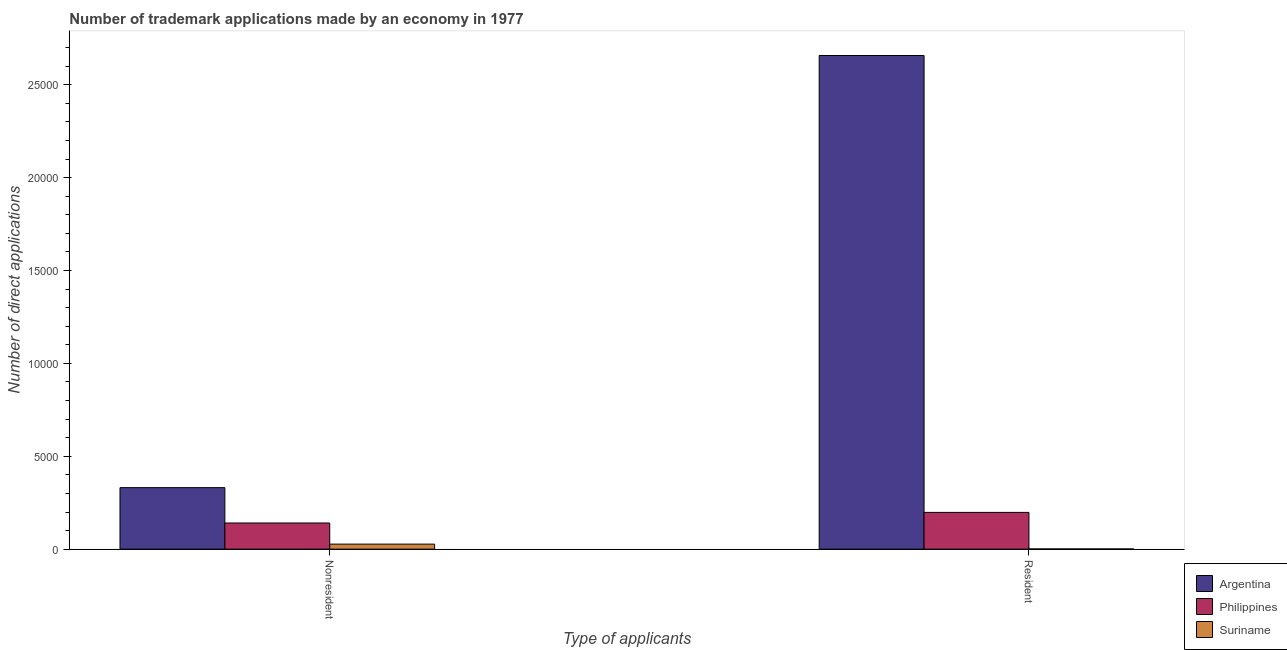How many different coloured bars are there?
Make the answer very short. 3. How many groups of bars are there?
Provide a succinct answer. 2. Are the number of bars on each tick of the X-axis equal?
Ensure brevity in your answer.  Yes. How many bars are there on the 2nd tick from the left?
Ensure brevity in your answer.  3. How many bars are there on the 2nd tick from the right?
Make the answer very short. 3. What is the label of the 1st group of bars from the left?
Offer a terse response. Nonresident. What is the number of trademark applications made by residents in Suriname?
Offer a very short reply. 10. Across all countries, what is the maximum number of trademark applications made by non residents?
Offer a very short reply. 3311. Across all countries, what is the minimum number of trademark applications made by residents?
Keep it short and to the point. 10. In which country was the number of trademark applications made by residents minimum?
Your response must be concise. Suriname. What is the total number of trademark applications made by residents in the graph?
Give a very brief answer. 2.86e+04. What is the difference between the number of trademark applications made by residents in Philippines and that in Argentina?
Your response must be concise. -2.46e+04. What is the difference between the number of trademark applications made by residents in Suriname and the number of trademark applications made by non residents in Argentina?
Provide a succinct answer. -3301. What is the average number of trademark applications made by non residents per country?
Offer a very short reply. 1663.33. What is the difference between the number of trademark applications made by residents and number of trademark applications made by non residents in Philippines?
Give a very brief answer. 571. What is the ratio of the number of trademark applications made by residents in Suriname to that in Philippines?
Your response must be concise. 0.01. How many countries are there in the graph?
Provide a short and direct response. 3. What is the difference between two consecutive major ticks on the Y-axis?
Your response must be concise. 5000. Does the graph contain any zero values?
Offer a terse response. No. Does the graph contain grids?
Make the answer very short. No. Where does the legend appear in the graph?
Give a very brief answer. Bottom right. What is the title of the graph?
Your answer should be very brief. Number of trademark applications made by an economy in 1977. What is the label or title of the X-axis?
Provide a succinct answer. Type of applicants. What is the label or title of the Y-axis?
Offer a terse response. Number of direct applications. What is the Number of direct applications in Argentina in Nonresident?
Ensure brevity in your answer.  3311. What is the Number of direct applications in Philippines in Nonresident?
Your response must be concise. 1408. What is the Number of direct applications in Suriname in Nonresident?
Your answer should be compact. 271. What is the Number of direct applications of Argentina in Resident?
Ensure brevity in your answer.  2.66e+04. What is the Number of direct applications in Philippines in Resident?
Give a very brief answer. 1979. What is the Number of direct applications of Suriname in Resident?
Ensure brevity in your answer.  10. Across all Type of applicants, what is the maximum Number of direct applications of Argentina?
Your answer should be compact. 2.66e+04. Across all Type of applicants, what is the maximum Number of direct applications of Philippines?
Keep it short and to the point. 1979. Across all Type of applicants, what is the maximum Number of direct applications of Suriname?
Offer a terse response. 271. Across all Type of applicants, what is the minimum Number of direct applications of Argentina?
Ensure brevity in your answer.  3311. Across all Type of applicants, what is the minimum Number of direct applications in Philippines?
Offer a terse response. 1408. What is the total Number of direct applications in Argentina in the graph?
Ensure brevity in your answer.  2.99e+04. What is the total Number of direct applications of Philippines in the graph?
Offer a very short reply. 3387. What is the total Number of direct applications of Suriname in the graph?
Offer a terse response. 281. What is the difference between the Number of direct applications in Argentina in Nonresident and that in Resident?
Your response must be concise. -2.33e+04. What is the difference between the Number of direct applications in Philippines in Nonresident and that in Resident?
Offer a terse response. -571. What is the difference between the Number of direct applications of Suriname in Nonresident and that in Resident?
Give a very brief answer. 261. What is the difference between the Number of direct applications in Argentina in Nonresident and the Number of direct applications in Philippines in Resident?
Your answer should be very brief. 1332. What is the difference between the Number of direct applications of Argentina in Nonresident and the Number of direct applications of Suriname in Resident?
Make the answer very short. 3301. What is the difference between the Number of direct applications of Philippines in Nonresident and the Number of direct applications of Suriname in Resident?
Offer a very short reply. 1398. What is the average Number of direct applications in Argentina per Type of applicants?
Your answer should be compact. 1.49e+04. What is the average Number of direct applications of Philippines per Type of applicants?
Your answer should be very brief. 1693.5. What is the average Number of direct applications of Suriname per Type of applicants?
Your answer should be compact. 140.5. What is the difference between the Number of direct applications of Argentina and Number of direct applications of Philippines in Nonresident?
Ensure brevity in your answer.  1903. What is the difference between the Number of direct applications in Argentina and Number of direct applications in Suriname in Nonresident?
Make the answer very short. 3040. What is the difference between the Number of direct applications of Philippines and Number of direct applications of Suriname in Nonresident?
Keep it short and to the point. 1137. What is the difference between the Number of direct applications of Argentina and Number of direct applications of Philippines in Resident?
Give a very brief answer. 2.46e+04. What is the difference between the Number of direct applications in Argentina and Number of direct applications in Suriname in Resident?
Make the answer very short. 2.66e+04. What is the difference between the Number of direct applications of Philippines and Number of direct applications of Suriname in Resident?
Your answer should be very brief. 1969. What is the ratio of the Number of direct applications of Argentina in Nonresident to that in Resident?
Make the answer very short. 0.12. What is the ratio of the Number of direct applications in Philippines in Nonresident to that in Resident?
Your answer should be compact. 0.71. What is the ratio of the Number of direct applications in Suriname in Nonresident to that in Resident?
Offer a very short reply. 27.1. What is the difference between the highest and the second highest Number of direct applications in Argentina?
Your answer should be very brief. 2.33e+04. What is the difference between the highest and the second highest Number of direct applications of Philippines?
Provide a succinct answer. 571. What is the difference between the highest and the second highest Number of direct applications in Suriname?
Offer a very short reply. 261. What is the difference between the highest and the lowest Number of direct applications in Argentina?
Offer a very short reply. 2.33e+04. What is the difference between the highest and the lowest Number of direct applications of Philippines?
Offer a very short reply. 571. What is the difference between the highest and the lowest Number of direct applications of Suriname?
Provide a succinct answer. 261. 